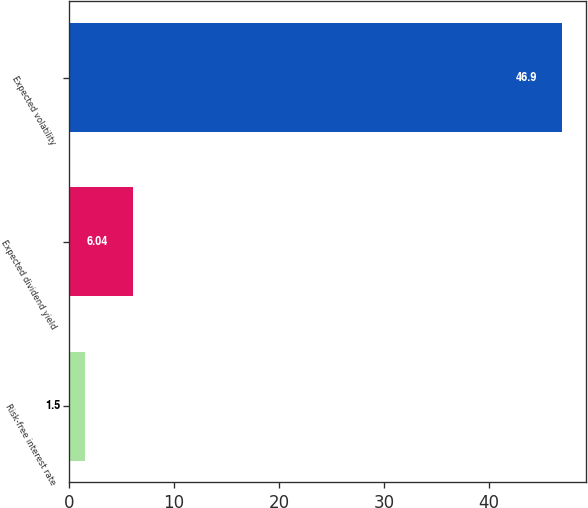<chart> <loc_0><loc_0><loc_500><loc_500><bar_chart><fcel>Risk-free interest rate<fcel>Expected dividend yield<fcel>Expected volatility<nl><fcel>1.5<fcel>6.04<fcel>46.9<nl></chart> 